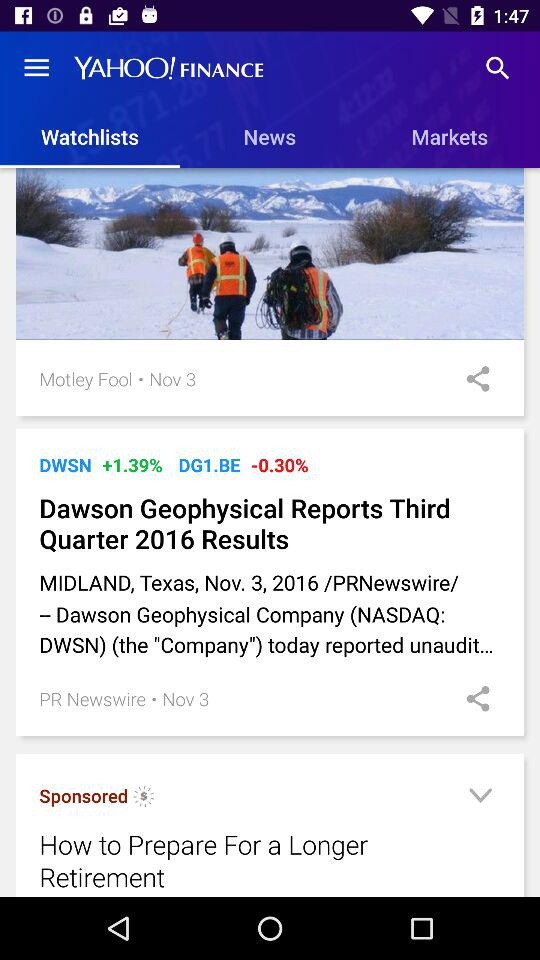Which tab is selected in "YAHOO! FINANCE"? The selected tab is "Watchlists". 